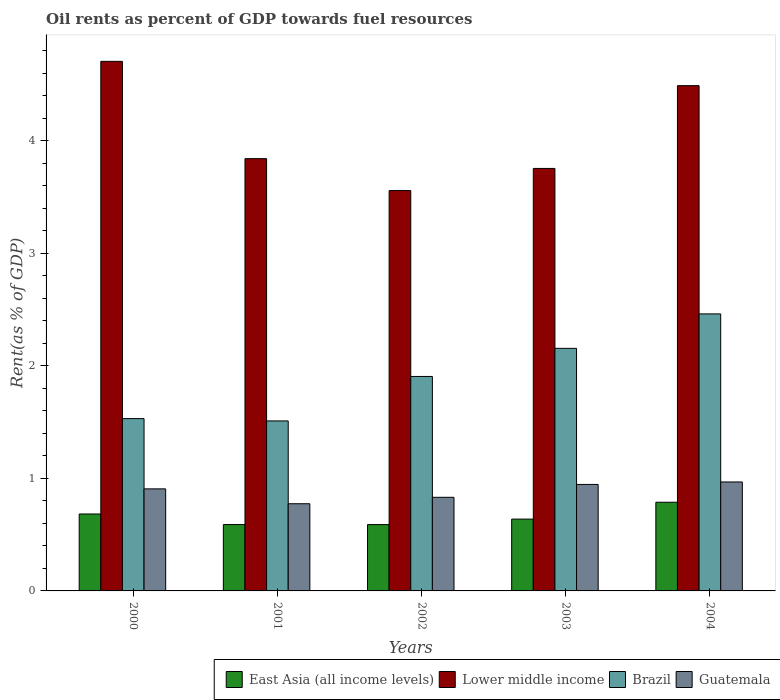Are the number of bars on each tick of the X-axis equal?
Keep it short and to the point. Yes. How many bars are there on the 2nd tick from the left?
Offer a terse response. 4. How many bars are there on the 4th tick from the right?
Make the answer very short. 4. In how many cases, is the number of bars for a given year not equal to the number of legend labels?
Offer a very short reply. 0. What is the oil rent in Lower middle income in 2002?
Offer a terse response. 3.56. Across all years, what is the maximum oil rent in Brazil?
Your answer should be compact. 2.46. Across all years, what is the minimum oil rent in East Asia (all income levels)?
Your response must be concise. 0.59. What is the total oil rent in Brazil in the graph?
Ensure brevity in your answer.  9.57. What is the difference between the oil rent in Lower middle income in 2001 and that in 2004?
Offer a terse response. -0.65. What is the difference between the oil rent in East Asia (all income levels) in 2000 and the oil rent in Lower middle income in 2003?
Your response must be concise. -3.07. What is the average oil rent in East Asia (all income levels) per year?
Make the answer very short. 0.66. In the year 2000, what is the difference between the oil rent in Lower middle income and oil rent in East Asia (all income levels)?
Your answer should be compact. 4.02. What is the ratio of the oil rent in Lower middle income in 2002 to that in 2003?
Offer a terse response. 0.95. What is the difference between the highest and the second highest oil rent in Guatemala?
Make the answer very short. 0.02. What is the difference between the highest and the lowest oil rent in Lower middle income?
Provide a succinct answer. 1.15. In how many years, is the oil rent in East Asia (all income levels) greater than the average oil rent in East Asia (all income levels) taken over all years?
Give a very brief answer. 2. What does the 2nd bar from the left in 2001 represents?
Offer a very short reply. Lower middle income. What does the 3rd bar from the right in 2004 represents?
Provide a succinct answer. Lower middle income. Is it the case that in every year, the sum of the oil rent in Guatemala and oil rent in Brazil is greater than the oil rent in Lower middle income?
Your answer should be compact. No. Are all the bars in the graph horizontal?
Make the answer very short. No. How many years are there in the graph?
Provide a short and direct response. 5. How many legend labels are there?
Give a very brief answer. 4. How are the legend labels stacked?
Provide a succinct answer. Horizontal. What is the title of the graph?
Provide a succinct answer. Oil rents as percent of GDP towards fuel resources. What is the label or title of the X-axis?
Your answer should be compact. Years. What is the label or title of the Y-axis?
Offer a terse response. Rent(as % of GDP). What is the Rent(as % of GDP) of East Asia (all income levels) in 2000?
Ensure brevity in your answer.  0.68. What is the Rent(as % of GDP) of Lower middle income in 2000?
Make the answer very short. 4.71. What is the Rent(as % of GDP) of Brazil in 2000?
Make the answer very short. 1.53. What is the Rent(as % of GDP) in Guatemala in 2000?
Your answer should be very brief. 0.91. What is the Rent(as % of GDP) of East Asia (all income levels) in 2001?
Make the answer very short. 0.59. What is the Rent(as % of GDP) of Lower middle income in 2001?
Make the answer very short. 3.84. What is the Rent(as % of GDP) in Brazil in 2001?
Your answer should be very brief. 1.51. What is the Rent(as % of GDP) in Guatemala in 2001?
Offer a terse response. 0.77. What is the Rent(as % of GDP) in East Asia (all income levels) in 2002?
Provide a succinct answer. 0.59. What is the Rent(as % of GDP) in Lower middle income in 2002?
Make the answer very short. 3.56. What is the Rent(as % of GDP) in Brazil in 2002?
Offer a very short reply. 1.91. What is the Rent(as % of GDP) in Guatemala in 2002?
Make the answer very short. 0.83. What is the Rent(as % of GDP) in East Asia (all income levels) in 2003?
Give a very brief answer. 0.64. What is the Rent(as % of GDP) in Lower middle income in 2003?
Your response must be concise. 3.75. What is the Rent(as % of GDP) in Brazil in 2003?
Your answer should be very brief. 2.16. What is the Rent(as % of GDP) of Guatemala in 2003?
Give a very brief answer. 0.95. What is the Rent(as % of GDP) in East Asia (all income levels) in 2004?
Give a very brief answer. 0.79. What is the Rent(as % of GDP) in Lower middle income in 2004?
Your answer should be very brief. 4.49. What is the Rent(as % of GDP) in Brazil in 2004?
Offer a very short reply. 2.46. What is the Rent(as % of GDP) in Guatemala in 2004?
Offer a very short reply. 0.97. Across all years, what is the maximum Rent(as % of GDP) of East Asia (all income levels)?
Offer a terse response. 0.79. Across all years, what is the maximum Rent(as % of GDP) of Lower middle income?
Your answer should be very brief. 4.71. Across all years, what is the maximum Rent(as % of GDP) in Brazil?
Your response must be concise. 2.46. Across all years, what is the maximum Rent(as % of GDP) of Guatemala?
Offer a terse response. 0.97. Across all years, what is the minimum Rent(as % of GDP) in East Asia (all income levels)?
Your answer should be compact. 0.59. Across all years, what is the minimum Rent(as % of GDP) of Lower middle income?
Ensure brevity in your answer.  3.56. Across all years, what is the minimum Rent(as % of GDP) of Brazil?
Ensure brevity in your answer.  1.51. Across all years, what is the minimum Rent(as % of GDP) of Guatemala?
Ensure brevity in your answer.  0.77. What is the total Rent(as % of GDP) of East Asia (all income levels) in the graph?
Provide a succinct answer. 3.29. What is the total Rent(as % of GDP) of Lower middle income in the graph?
Your answer should be compact. 20.35. What is the total Rent(as % of GDP) of Brazil in the graph?
Offer a terse response. 9.57. What is the total Rent(as % of GDP) of Guatemala in the graph?
Ensure brevity in your answer.  4.43. What is the difference between the Rent(as % of GDP) of East Asia (all income levels) in 2000 and that in 2001?
Offer a very short reply. 0.09. What is the difference between the Rent(as % of GDP) in Lower middle income in 2000 and that in 2001?
Offer a terse response. 0.86. What is the difference between the Rent(as % of GDP) in Brazil in 2000 and that in 2001?
Offer a terse response. 0.02. What is the difference between the Rent(as % of GDP) in Guatemala in 2000 and that in 2001?
Your answer should be compact. 0.13. What is the difference between the Rent(as % of GDP) in East Asia (all income levels) in 2000 and that in 2002?
Make the answer very short. 0.09. What is the difference between the Rent(as % of GDP) in Lower middle income in 2000 and that in 2002?
Your response must be concise. 1.15. What is the difference between the Rent(as % of GDP) in Brazil in 2000 and that in 2002?
Offer a very short reply. -0.37. What is the difference between the Rent(as % of GDP) in Guatemala in 2000 and that in 2002?
Make the answer very short. 0.07. What is the difference between the Rent(as % of GDP) in East Asia (all income levels) in 2000 and that in 2003?
Make the answer very short. 0.05. What is the difference between the Rent(as % of GDP) in Lower middle income in 2000 and that in 2003?
Ensure brevity in your answer.  0.95. What is the difference between the Rent(as % of GDP) of Brazil in 2000 and that in 2003?
Keep it short and to the point. -0.62. What is the difference between the Rent(as % of GDP) in Guatemala in 2000 and that in 2003?
Make the answer very short. -0.04. What is the difference between the Rent(as % of GDP) in East Asia (all income levels) in 2000 and that in 2004?
Ensure brevity in your answer.  -0.1. What is the difference between the Rent(as % of GDP) in Lower middle income in 2000 and that in 2004?
Offer a terse response. 0.22. What is the difference between the Rent(as % of GDP) in Brazil in 2000 and that in 2004?
Provide a short and direct response. -0.93. What is the difference between the Rent(as % of GDP) in Guatemala in 2000 and that in 2004?
Give a very brief answer. -0.06. What is the difference between the Rent(as % of GDP) of Lower middle income in 2001 and that in 2002?
Provide a short and direct response. 0.28. What is the difference between the Rent(as % of GDP) of Brazil in 2001 and that in 2002?
Ensure brevity in your answer.  -0.4. What is the difference between the Rent(as % of GDP) in Guatemala in 2001 and that in 2002?
Your answer should be very brief. -0.06. What is the difference between the Rent(as % of GDP) of East Asia (all income levels) in 2001 and that in 2003?
Ensure brevity in your answer.  -0.05. What is the difference between the Rent(as % of GDP) in Lower middle income in 2001 and that in 2003?
Make the answer very short. 0.09. What is the difference between the Rent(as % of GDP) in Brazil in 2001 and that in 2003?
Give a very brief answer. -0.65. What is the difference between the Rent(as % of GDP) in Guatemala in 2001 and that in 2003?
Make the answer very short. -0.17. What is the difference between the Rent(as % of GDP) of East Asia (all income levels) in 2001 and that in 2004?
Your answer should be compact. -0.2. What is the difference between the Rent(as % of GDP) in Lower middle income in 2001 and that in 2004?
Your answer should be very brief. -0.65. What is the difference between the Rent(as % of GDP) in Brazil in 2001 and that in 2004?
Make the answer very short. -0.95. What is the difference between the Rent(as % of GDP) in Guatemala in 2001 and that in 2004?
Offer a very short reply. -0.19. What is the difference between the Rent(as % of GDP) in East Asia (all income levels) in 2002 and that in 2003?
Your answer should be very brief. -0.05. What is the difference between the Rent(as % of GDP) in Lower middle income in 2002 and that in 2003?
Your answer should be compact. -0.2. What is the difference between the Rent(as % of GDP) of Brazil in 2002 and that in 2003?
Your response must be concise. -0.25. What is the difference between the Rent(as % of GDP) of Guatemala in 2002 and that in 2003?
Your answer should be compact. -0.11. What is the difference between the Rent(as % of GDP) of East Asia (all income levels) in 2002 and that in 2004?
Your answer should be very brief. -0.2. What is the difference between the Rent(as % of GDP) in Lower middle income in 2002 and that in 2004?
Ensure brevity in your answer.  -0.93. What is the difference between the Rent(as % of GDP) in Brazil in 2002 and that in 2004?
Provide a short and direct response. -0.56. What is the difference between the Rent(as % of GDP) of Guatemala in 2002 and that in 2004?
Offer a very short reply. -0.14. What is the difference between the Rent(as % of GDP) in East Asia (all income levels) in 2003 and that in 2004?
Your answer should be very brief. -0.15. What is the difference between the Rent(as % of GDP) in Lower middle income in 2003 and that in 2004?
Your answer should be compact. -0.74. What is the difference between the Rent(as % of GDP) in Brazil in 2003 and that in 2004?
Offer a terse response. -0.31. What is the difference between the Rent(as % of GDP) of Guatemala in 2003 and that in 2004?
Make the answer very short. -0.02. What is the difference between the Rent(as % of GDP) of East Asia (all income levels) in 2000 and the Rent(as % of GDP) of Lower middle income in 2001?
Keep it short and to the point. -3.16. What is the difference between the Rent(as % of GDP) of East Asia (all income levels) in 2000 and the Rent(as % of GDP) of Brazil in 2001?
Your answer should be compact. -0.83. What is the difference between the Rent(as % of GDP) of East Asia (all income levels) in 2000 and the Rent(as % of GDP) of Guatemala in 2001?
Ensure brevity in your answer.  -0.09. What is the difference between the Rent(as % of GDP) in Lower middle income in 2000 and the Rent(as % of GDP) in Brazil in 2001?
Offer a very short reply. 3.2. What is the difference between the Rent(as % of GDP) in Lower middle income in 2000 and the Rent(as % of GDP) in Guatemala in 2001?
Offer a very short reply. 3.93. What is the difference between the Rent(as % of GDP) of Brazil in 2000 and the Rent(as % of GDP) of Guatemala in 2001?
Your answer should be very brief. 0.76. What is the difference between the Rent(as % of GDP) in East Asia (all income levels) in 2000 and the Rent(as % of GDP) in Lower middle income in 2002?
Your response must be concise. -2.87. What is the difference between the Rent(as % of GDP) in East Asia (all income levels) in 2000 and the Rent(as % of GDP) in Brazil in 2002?
Make the answer very short. -1.22. What is the difference between the Rent(as % of GDP) in East Asia (all income levels) in 2000 and the Rent(as % of GDP) in Guatemala in 2002?
Keep it short and to the point. -0.15. What is the difference between the Rent(as % of GDP) in Lower middle income in 2000 and the Rent(as % of GDP) in Brazil in 2002?
Offer a very short reply. 2.8. What is the difference between the Rent(as % of GDP) of Lower middle income in 2000 and the Rent(as % of GDP) of Guatemala in 2002?
Give a very brief answer. 3.87. What is the difference between the Rent(as % of GDP) in Brazil in 2000 and the Rent(as % of GDP) in Guatemala in 2002?
Your answer should be compact. 0.7. What is the difference between the Rent(as % of GDP) in East Asia (all income levels) in 2000 and the Rent(as % of GDP) in Lower middle income in 2003?
Provide a succinct answer. -3.07. What is the difference between the Rent(as % of GDP) of East Asia (all income levels) in 2000 and the Rent(as % of GDP) of Brazil in 2003?
Provide a succinct answer. -1.47. What is the difference between the Rent(as % of GDP) in East Asia (all income levels) in 2000 and the Rent(as % of GDP) in Guatemala in 2003?
Keep it short and to the point. -0.26. What is the difference between the Rent(as % of GDP) in Lower middle income in 2000 and the Rent(as % of GDP) in Brazil in 2003?
Offer a terse response. 2.55. What is the difference between the Rent(as % of GDP) of Lower middle income in 2000 and the Rent(as % of GDP) of Guatemala in 2003?
Your response must be concise. 3.76. What is the difference between the Rent(as % of GDP) in Brazil in 2000 and the Rent(as % of GDP) in Guatemala in 2003?
Your response must be concise. 0.59. What is the difference between the Rent(as % of GDP) in East Asia (all income levels) in 2000 and the Rent(as % of GDP) in Lower middle income in 2004?
Keep it short and to the point. -3.81. What is the difference between the Rent(as % of GDP) of East Asia (all income levels) in 2000 and the Rent(as % of GDP) of Brazil in 2004?
Keep it short and to the point. -1.78. What is the difference between the Rent(as % of GDP) of East Asia (all income levels) in 2000 and the Rent(as % of GDP) of Guatemala in 2004?
Provide a succinct answer. -0.28. What is the difference between the Rent(as % of GDP) in Lower middle income in 2000 and the Rent(as % of GDP) in Brazil in 2004?
Your response must be concise. 2.24. What is the difference between the Rent(as % of GDP) of Lower middle income in 2000 and the Rent(as % of GDP) of Guatemala in 2004?
Ensure brevity in your answer.  3.74. What is the difference between the Rent(as % of GDP) in Brazil in 2000 and the Rent(as % of GDP) in Guatemala in 2004?
Offer a terse response. 0.56. What is the difference between the Rent(as % of GDP) of East Asia (all income levels) in 2001 and the Rent(as % of GDP) of Lower middle income in 2002?
Your response must be concise. -2.97. What is the difference between the Rent(as % of GDP) in East Asia (all income levels) in 2001 and the Rent(as % of GDP) in Brazil in 2002?
Provide a succinct answer. -1.32. What is the difference between the Rent(as % of GDP) of East Asia (all income levels) in 2001 and the Rent(as % of GDP) of Guatemala in 2002?
Ensure brevity in your answer.  -0.24. What is the difference between the Rent(as % of GDP) of Lower middle income in 2001 and the Rent(as % of GDP) of Brazil in 2002?
Provide a succinct answer. 1.94. What is the difference between the Rent(as % of GDP) in Lower middle income in 2001 and the Rent(as % of GDP) in Guatemala in 2002?
Provide a succinct answer. 3.01. What is the difference between the Rent(as % of GDP) in Brazil in 2001 and the Rent(as % of GDP) in Guatemala in 2002?
Provide a succinct answer. 0.68. What is the difference between the Rent(as % of GDP) of East Asia (all income levels) in 2001 and the Rent(as % of GDP) of Lower middle income in 2003?
Your answer should be very brief. -3.17. What is the difference between the Rent(as % of GDP) of East Asia (all income levels) in 2001 and the Rent(as % of GDP) of Brazil in 2003?
Your response must be concise. -1.57. What is the difference between the Rent(as % of GDP) of East Asia (all income levels) in 2001 and the Rent(as % of GDP) of Guatemala in 2003?
Ensure brevity in your answer.  -0.36. What is the difference between the Rent(as % of GDP) of Lower middle income in 2001 and the Rent(as % of GDP) of Brazil in 2003?
Give a very brief answer. 1.69. What is the difference between the Rent(as % of GDP) in Lower middle income in 2001 and the Rent(as % of GDP) in Guatemala in 2003?
Provide a succinct answer. 2.9. What is the difference between the Rent(as % of GDP) of Brazil in 2001 and the Rent(as % of GDP) of Guatemala in 2003?
Provide a succinct answer. 0.56. What is the difference between the Rent(as % of GDP) in East Asia (all income levels) in 2001 and the Rent(as % of GDP) in Lower middle income in 2004?
Your response must be concise. -3.9. What is the difference between the Rent(as % of GDP) in East Asia (all income levels) in 2001 and the Rent(as % of GDP) in Brazil in 2004?
Offer a very short reply. -1.87. What is the difference between the Rent(as % of GDP) in East Asia (all income levels) in 2001 and the Rent(as % of GDP) in Guatemala in 2004?
Provide a succinct answer. -0.38. What is the difference between the Rent(as % of GDP) of Lower middle income in 2001 and the Rent(as % of GDP) of Brazil in 2004?
Make the answer very short. 1.38. What is the difference between the Rent(as % of GDP) of Lower middle income in 2001 and the Rent(as % of GDP) of Guatemala in 2004?
Ensure brevity in your answer.  2.87. What is the difference between the Rent(as % of GDP) of Brazil in 2001 and the Rent(as % of GDP) of Guatemala in 2004?
Provide a short and direct response. 0.54. What is the difference between the Rent(as % of GDP) of East Asia (all income levels) in 2002 and the Rent(as % of GDP) of Lower middle income in 2003?
Offer a terse response. -3.17. What is the difference between the Rent(as % of GDP) in East Asia (all income levels) in 2002 and the Rent(as % of GDP) in Brazil in 2003?
Your response must be concise. -1.57. What is the difference between the Rent(as % of GDP) in East Asia (all income levels) in 2002 and the Rent(as % of GDP) in Guatemala in 2003?
Offer a terse response. -0.36. What is the difference between the Rent(as % of GDP) of Lower middle income in 2002 and the Rent(as % of GDP) of Brazil in 2003?
Offer a very short reply. 1.4. What is the difference between the Rent(as % of GDP) of Lower middle income in 2002 and the Rent(as % of GDP) of Guatemala in 2003?
Offer a terse response. 2.61. What is the difference between the Rent(as % of GDP) of Brazil in 2002 and the Rent(as % of GDP) of Guatemala in 2003?
Ensure brevity in your answer.  0.96. What is the difference between the Rent(as % of GDP) of East Asia (all income levels) in 2002 and the Rent(as % of GDP) of Lower middle income in 2004?
Your answer should be compact. -3.9. What is the difference between the Rent(as % of GDP) in East Asia (all income levels) in 2002 and the Rent(as % of GDP) in Brazil in 2004?
Offer a very short reply. -1.87. What is the difference between the Rent(as % of GDP) of East Asia (all income levels) in 2002 and the Rent(as % of GDP) of Guatemala in 2004?
Offer a very short reply. -0.38. What is the difference between the Rent(as % of GDP) of Lower middle income in 2002 and the Rent(as % of GDP) of Brazil in 2004?
Offer a terse response. 1.1. What is the difference between the Rent(as % of GDP) of Lower middle income in 2002 and the Rent(as % of GDP) of Guatemala in 2004?
Make the answer very short. 2.59. What is the difference between the Rent(as % of GDP) in Brazil in 2002 and the Rent(as % of GDP) in Guatemala in 2004?
Your answer should be compact. 0.94. What is the difference between the Rent(as % of GDP) of East Asia (all income levels) in 2003 and the Rent(as % of GDP) of Lower middle income in 2004?
Provide a short and direct response. -3.85. What is the difference between the Rent(as % of GDP) in East Asia (all income levels) in 2003 and the Rent(as % of GDP) in Brazil in 2004?
Offer a terse response. -1.82. What is the difference between the Rent(as % of GDP) of East Asia (all income levels) in 2003 and the Rent(as % of GDP) of Guatemala in 2004?
Your response must be concise. -0.33. What is the difference between the Rent(as % of GDP) in Lower middle income in 2003 and the Rent(as % of GDP) in Brazil in 2004?
Your answer should be very brief. 1.29. What is the difference between the Rent(as % of GDP) of Lower middle income in 2003 and the Rent(as % of GDP) of Guatemala in 2004?
Keep it short and to the point. 2.79. What is the difference between the Rent(as % of GDP) in Brazil in 2003 and the Rent(as % of GDP) in Guatemala in 2004?
Provide a short and direct response. 1.19. What is the average Rent(as % of GDP) of East Asia (all income levels) per year?
Make the answer very short. 0.66. What is the average Rent(as % of GDP) in Lower middle income per year?
Make the answer very short. 4.07. What is the average Rent(as % of GDP) of Brazil per year?
Ensure brevity in your answer.  1.91. What is the average Rent(as % of GDP) in Guatemala per year?
Provide a short and direct response. 0.89. In the year 2000, what is the difference between the Rent(as % of GDP) of East Asia (all income levels) and Rent(as % of GDP) of Lower middle income?
Your response must be concise. -4.02. In the year 2000, what is the difference between the Rent(as % of GDP) in East Asia (all income levels) and Rent(as % of GDP) in Brazil?
Ensure brevity in your answer.  -0.85. In the year 2000, what is the difference between the Rent(as % of GDP) in East Asia (all income levels) and Rent(as % of GDP) in Guatemala?
Provide a succinct answer. -0.22. In the year 2000, what is the difference between the Rent(as % of GDP) of Lower middle income and Rent(as % of GDP) of Brazil?
Make the answer very short. 3.18. In the year 2000, what is the difference between the Rent(as % of GDP) of Lower middle income and Rent(as % of GDP) of Guatemala?
Give a very brief answer. 3.8. In the year 2000, what is the difference between the Rent(as % of GDP) of Brazil and Rent(as % of GDP) of Guatemala?
Provide a succinct answer. 0.62. In the year 2001, what is the difference between the Rent(as % of GDP) in East Asia (all income levels) and Rent(as % of GDP) in Lower middle income?
Your response must be concise. -3.25. In the year 2001, what is the difference between the Rent(as % of GDP) in East Asia (all income levels) and Rent(as % of GDP) in Brazil?
Offer a very short reply. -0.92. In the year 2001, what is the difference between the Rent(as % of GDP) in East Asia (all income levels) and Rent(as % of GDP) in Guatemala?
Your answer should be very brief. -0.18. In the year 2001, what is the difference between the Rent(as % of GDP) in Lower middle income and Rent(as % of GDP) in Brazil?
Give a very brief answer. 2.33. In the year 2001, what is the difference between the Rent(as % of GDP) in Lower middle income and Rent(as % of GDP) in Guatemala?
Your answer should be compact. 3.07. In the year 2001, what is the difference between the Rent(as % of GDP) of Brazil and Rent(as % of GDP) of Guatemala?
Provide a short and direct response. 0.74. In the year 2002, what is the difference between the Rent(as % of GDP) of East Asia (all income levels) and Rent(as % of GDP) of Lower middle income?
Your answer should be very brief. -2.97. In the year 2002, what is the difference between the Rent(as % of GDP) in East Asia (all income levels) and Rent(as % of GDP) in Brazil?
Your answer should be very brief. -1.32. In the year 2002, what is the difference between the Rent(as % of GDP) of East Asia (all income levels) and Rent(as % of GDP) of Guatemala?
Your answer should be very brief. -0.24. In the year 2002, what is the difference between the Rent(as % of GDP) in Lower middle income and Rent(as % of GDP) in Brazil?
Ensure brevity in your answer.  1.65. In the year 2002, what is the difference between the Rent(as % of GDP) of Lower middle income and Rent(as % of GDP) of Guatemala?
Your answer should be compact. 2.73. In the year 2002, what is the difference between the Rent(as % of GDP) of Brazil and Rent(as % of GDP) of Guatemala?
Keep it short and to the point. 1.07. In the year 2003, what is the difference between the Rent(as % of GDP) in East Asia (all income levels) and Rent(as % of GDP) in Lower middle income?
Ensure brevity in your answer.  -3.12. In the year 2003, what is the difference between the Rent(as % of GDP) in East Asia (all income levels) and Rent(as % of GDP) in Brazil?
Provide a succinct answer. -1.52. In the year 2003, what is the difference between the Rent(as % of GDP) in East Asia (all income levels) and Rent(as % of GDP) in Guatemala?
Make the answer very short. -0.31. In the year 2003, what is the difference between the Rent(as % of GDP) of Lower middle income and Rent(as % of GDP) of Brazil?
Provide a succinct answer. 1.6. In the year 2003, what is the difference between the Rent(as % of GDP) in Lower middle income and Rent(as % of GDP) in Guatemala?
Give a very brief answer. 2.81. In the year 2003, what is the difference between the Rent(as % of GDP) of Brazil and Rent(as % of GDP) of Guatemala?
Offer a very short reply. 1.21. In the year 2004, what is the difference between the Rent(as % of GDP) in East Asia (all income levels) and Rent(as % of GDP) in Lower middle income?
Give a very brief answer. -3.7. In the year 2004, what is the difference between the Rent(as % of GDP) of East Asia (all income levels) and Rent(as % of GDP) of Brazil?
Ensure brevity in your answer.  -1.67. In the year 2004, what is the difference between the Rent(as % of GDP) of East Asia (all income levels) and Rent(as % of GDP) of Guatemala?
Your response must be concise. -0.18. In the year 2004, what is the difference between the Rent(as % of GDP) in Lower middle income and Rent(as % of GDP) in Brazil?
Ensure brevity in your answer.  2.03. In the year 2004, what is the difference between the Rent(as % of GDP) in Lower middle income and Rent(as % of GDP) in Guatemala?
Ensure brevity in your answer.  3.52. In the year 2004, what is the difference between the Rent(as % of GDP) of Brazil and Rent(as % of GDP) of Guatemala?
Your answer should be very brief. 1.49. What is the ratio of the Rent(as % of GDP) in East Asia (all income levels) in 2000 to that in 2001?
Provide a succinct answer. 1.16. What is the ratio of the Rent(as % of GDP) of Lower middle income in 2000 to that in 2001?
Ensure brevity in your answer.  1.23. What is the ratio of the Rent(as % of GDP) in Brazil in 2000 to that in 2001?
Keep it short and to the point. 1.01. What is the ratio of the Rent(as % of GDP) of Guatemala in 2000 to that in 2001?
Keep it short and to the point. 1.17. What is the ratio of the Rent(as % of GDP) of East Asia (all income levels) in 2000 to that in 2002?
Ensure brevity in your answer.  1.16. What is the ratio of the Rent(as % of GDP) in Lower middle income in 2000 to that in 2002?
Offer a terse response. 1.32. What is the ratio of the Rent(as % of GDP) in Brazil in 2000 to that in 2002?
Ensure brevity in your answer.  0.8. What is the ratio of the Rent(as % of GDP) in Guatemala in 2000 to that in 2002?
Ensure brevity in your answer.  1.09. What is the ratio of the Rent(as % of GDP) of East Asia (all income levels) in 2000 to that in 2003?
Keep it short and to the point. 1.07. What is the ratio of the Rent(as % of GDP) of Lower middle income in 2000 to that in 2003?
Your answer should be very brief. 1.25. What is the ratio of the Rent(as % of GDP) of Brazil in 2000 to that in 2003?
Offer a very short reply. 0.71. What is the ratio of the Rent(as % of GDP) of Guatemala in 2000 to that in 2003?
Keep it short and to the point. 0.96. What is the ratio of the Rent(as % of GDP) in East Asia (all income levels) in 2000 to that in 2004?
Ensure brevity in your answer.  0.87. What is the ratio of the Rent(as % of GDP) in Lower middle income in 2000 to that in 2004?
Keep it short and to the point. 1.05. What is the ratio of the Rent(as % of GDP) in Brazil in 2000 to that in 2004?
Ensure brevity in your answer.  0.62. What is the ratio of the Rent(as % of GDP) of Guatemala in 2000 to that in 2004?
Provide a short and direct response. 0.94. What is the ratio of the Rent(as % of GDP) of Lower middle income in 2001 to that in 2002?
Your answer should be very brief. 1.08. What is the ratio of the Rent(as % of GDP) of Brazil in 2001 to that in 2002?
Offer a terse response. 0.79. What is the ratio of the Rent(as % of GDP) in Guatemala in 2001 to that in 2002?
Make the answer very short. 0.93. What is the ratio of the Rent(as % of GDP) in East Asia (all income levels) in 2001 to that in 2003?
Provide a short and direct response. 0.92. What is the ratio of the Rent(as % of GDP) of Lower middle income in 2001 to that in 2003?
Ensure brevity in your answer.  1.02. What is the ratio of the Rent(as % of GDP) of Brazil in 2001 to that in 2003?
Your answer should be very brief. 0.7. What is the ratio of the Rent(as % of GDP) in Guatemala in 2001 to that in 2003?
Ensure brevity in your answer.  0.82. What is the ratio of the Rent(as % of GDP) of East Asia (all income levels) in 2001 to that in 2004?
Give a very brief answer. 0.75. What is the ratio of the Rent(as % of GDP) in Lower middle income in 2001 to that in 2004?
Your answer should be compact. 0.86. What is the ratio of the Rent(as % of GDP) in Brazil in 2001 to that in 2004?
Offer a terse response. 0.61. What is the ratio of the Rent(as % of GDP) of East Asia (all income levels) in 2002 to that in 2003?
Give a very brief answer. 0.92. What is the ratio of the Rent(as % of GDP) of Lower middle income in 2002 to that in 2003?
Make the answer very short. 0.95. What is the ratio of the Rent(as % of GDP) in Brazil in 2002 to that in 2003?
Your answer should be very brief. 0.88. What is the ratio of the Rent(as % of GDP) in Guatemala in 2002 to that in 2003?
Your answer should be compact. 0.88. What is the ratio of the Rent(as % of GDP) in East Asia (all income levels) in 2002 to that in 2004?
Your answer should be very brief. 0.75. What is the ratio of the Rent(as % of GDP) of Lower middle income in 2002 to that in 2004?
Offer a very short reply. 0.79. What is the ratio of the Rent(as % of GDP) of Brazil in 2002 to that in 2004?
Give a very brief answer. 0.77. What is the ratio of the Rent(as % of GDP) of Guatemala in 2002 to that in 2004?
Your response must be concise. 0.86. What is the ratio of the Rent(as % of GDP) of East Asia (all income levels) in 2003 to that in 2004?
Your response must be concise. 0.81. What is the ratio of the Rent(as % of GDP) in Lower middle income in 2003 to that in 2004?
Ensure brevity in your answer.  0.84. What is the ratio of the Rent(as % of GDP) in Brazil in 2003 to that in 2004?
Your answer should be very brief. 0.88. What is the ratio of the Rent(as % of GDP) in Guatemala in 2003 to that in 2004?
Offer a terse response. 0.98. What is the difference between the highest and the second highest Rent(as % of GDP) in East Asia (all income levels)?
Offer a very short reply. 0.1. What is the difference between the highest and the second highest Rent(as % of GDP) in Lower middle income?
Ensure brevity in your answer.  0.22. What is the difference between the highest and the second highest Rent(as % of GDP) of Brazil?
Provide a short and direct response. 0.31. What is the difference between the highest and the second highest Rent(as % of GDP) in Guatemala?
Give a very brief answer. 0.02. What is the difference between the highest and the lowest Rent(as % of GDP) of East Asia (all income levels)?
Provide a succinct answer. 0.2. What is the difference between the highest and the lowest Rent(as % of GDP) of Lower middle income?
Your answer should be compact. 1.15. What is the difference between the highest and the lowest Rent(as % of GDP) of Brazil?
Offer a very short reply. 0.95. What is the difference between the highest and the lowest Rent(as % of GDP) of Guatemala?
Offer a terse response. 0.19. 